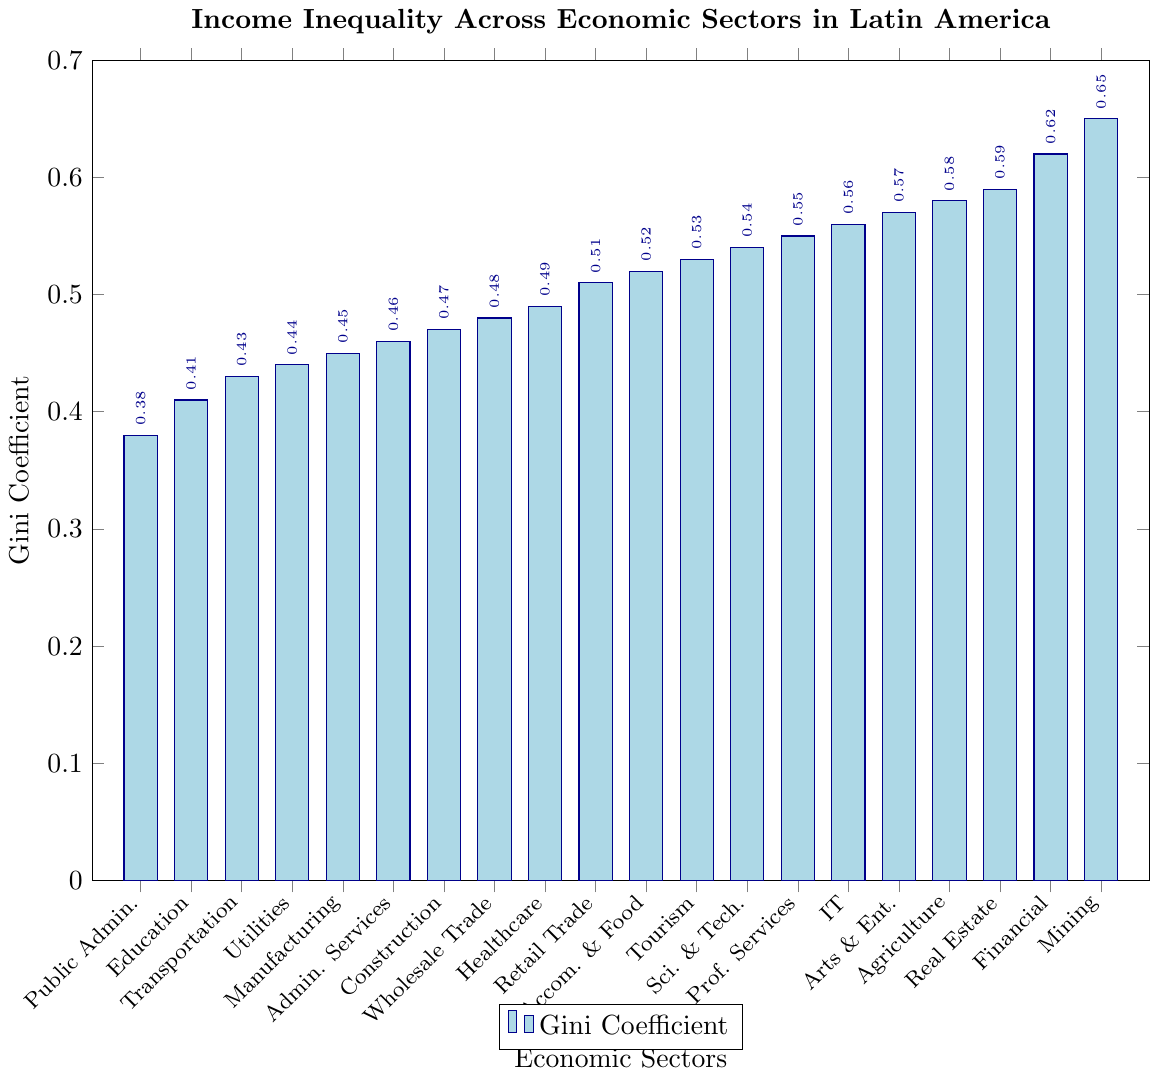Which sector has the highest Gini Coefficient? Look at the plotted bars and find the bar that reaches the highest on the vertical axis labeled 'Gini Coefficient'. The bar representing 'Mining' is the highest.
Answer: Mining Which sector has the lowest Gini Coefficient? Look at the plotted bars and find the bar that reaches the lowest on the vertical axis labeled 'Gini Coefficient'. The bar representing 'Public Administration' is the lowest.
Answer: Public Administration How much higher is the Gini Coefficient of Financial Services compared to Healthcare? Locate the bar for Financial Services and Healthcare. Subtract the Gini Coefficient of Healthcare (0.49) from Financial Services (0.62). The difference is 0.62 - 0.49 = 0.13.
Answer: 0.13 What is the average Gini Coefficient of the top three sectors with the highest inequality? Identify the top three sectors: Mining (0.65), Financial Services (0.62), and Real Estate (0.59). Calculate their average: (0.65 + 0.62 + 0.59) / 3 = 1.86 / 3 = 0.62.
Answer: 0.62 Which sectors have a Gini Coefficient below 0.45? Identify bars with values below 0.45: Public Administration (0.38), Education (0.41), Transportation (0.43), and Utilities (0.44).
Answer: Public Administration, Education, Transportation, Utilities Which sector's Gini Coefficient is closest to the median value of all sectors' coefficients? List all coefficients in ascending order and find the median value (middle value). The values in order are 0.38, 0.41, 0.43, 0.44, 0.45, 0.46, 0.47, 0.48, 0.49, 0.51, 0.52, 0.53, 0.54, 0.55, 0.56, 0.57, 0.58, 0.59, 0.62, 0.65. Middle two values are 0.49 and 0.51; median is (0.49+0.51)/2 = 0.50. The sector closest to 0.50 is Retail Trade with 0.51.
Answer: Retail Trade How do the Gini Coefficients of Administrative Services compare to Scientific and Technical Services? Locate the bars for Administrative Services (0.46) and Scientific and Technical Services (0.54). Compare the two values, noting that 0.46 is less than 0.54.
Answer: Administrative Services < Scientific and Technical Services If we rank the sectors based on their Gini Coefficients, which position does the Information Technology sector hold? List all coefficients in ascending order and find the position for Information Technology (0.56). The order is 0.38, 0.41, 0.43, 0.44, 0.45, 0.46, 0.47, 0.48, 0.49, 0.51, 0.52, 0.53, 0.54, 0.55, 0.56, 0.57, 0.58, 0.59, 0.62, 0.65. Information Technology is in the 15th position.
Answer: 15th What is the difference between the Gini Coefficient of Arts and Entertainment and Professional Services? Locate the bars for Arts and Entertainment (0.57) and Professional Services (0.55). Subtract the Gini Coefficient of Professional Services from Arts and Entertainment: 0.57 - 0.55 = 0.02.
Answer: 0.02 